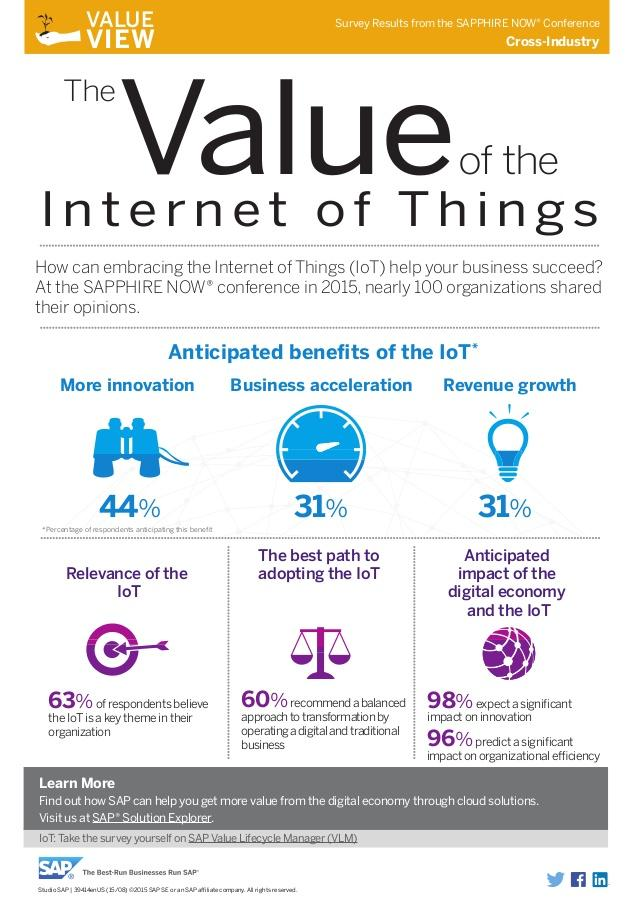Point out several critical features in this image. According to a recent survey, 31% of businesses believe that embracing the Internet of Things (IoT) will lead to revenue growth and accelerate their business. According to the belief, 98% of people think that IoT can influence ideation. 